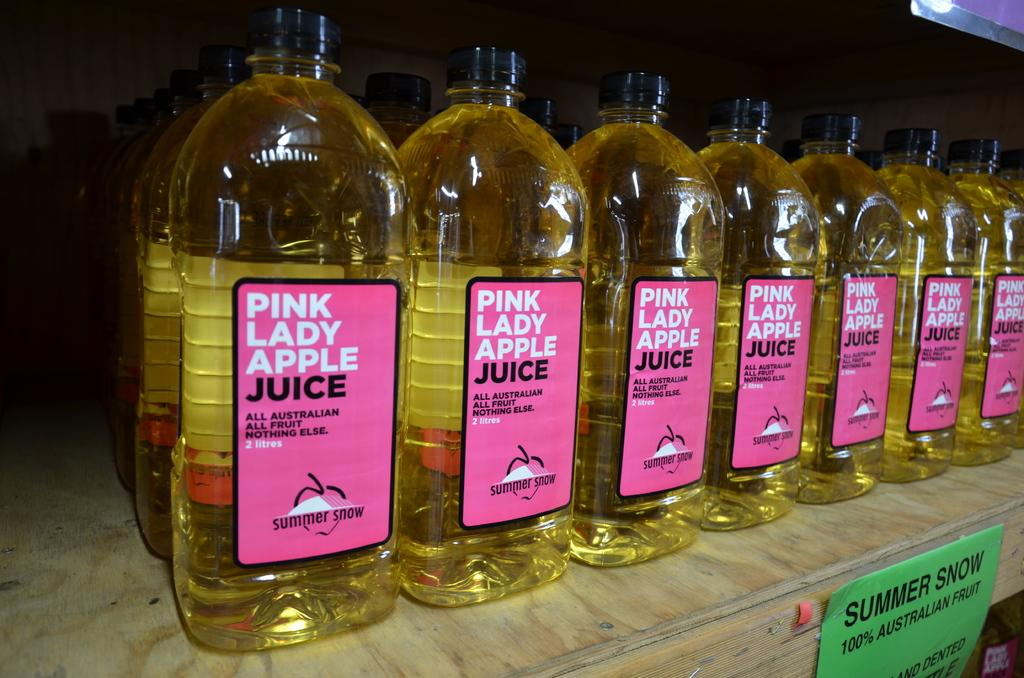<image>
Write a terse but informative summary of the picture. Seven bottles of Pink Lady Apple Juice standing side by side on a retail shelf. 